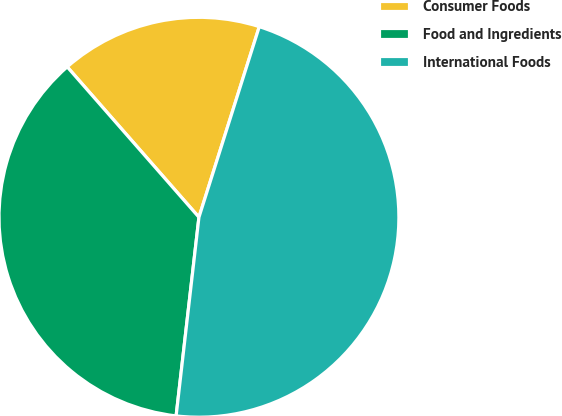<chart> <loc_0><loc_0><loc_500><loc_500><pie_chart><fcel>Consumer Foods<fcel>Food and Ingredients<fcel>International Foods<nl><fcel>16.33%<fcel>36.73%<fcel>46.94%<nl></chart> 